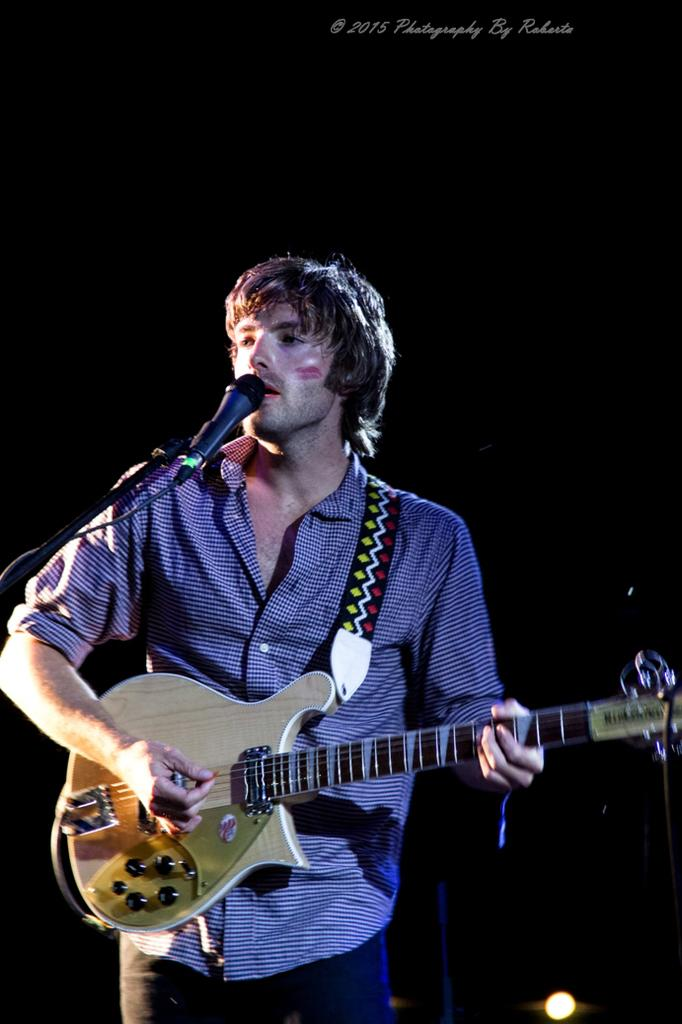What is the man in the image doing? The man is playing the guitar and singing into a microphone. What is the man's posture in the image? The man is standing. What is the man wearing in the image? The man is wearing a shirt. What type of silver object is the man using to play the guitar in the image? There is no silver object mentioned in the image; the man is simply playing the guitar. How many songs is the man singing in the image? The image does not specify the number of songs the man is singing; he is only depicted singing into a microphone. 